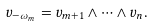Convert formula to latex. <formula><loc_0><loc_0><loc_500><loc_500>v _ { - \omega _ { m } } = v _ { m + 1 } \wedge \cdots \wedge v _ { n } .</formula> 